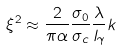Convert formula to latex. <formula><loc_0><loc_0><loc_500><loc_500>\xi ^ { 2 } \approx \frac { 2 } { \pi \alpha } \frac { \sigma _ { 0 } } { \sigma _ { c } } \frac { \lambda } { l _ { \gamma } } k</formula> 